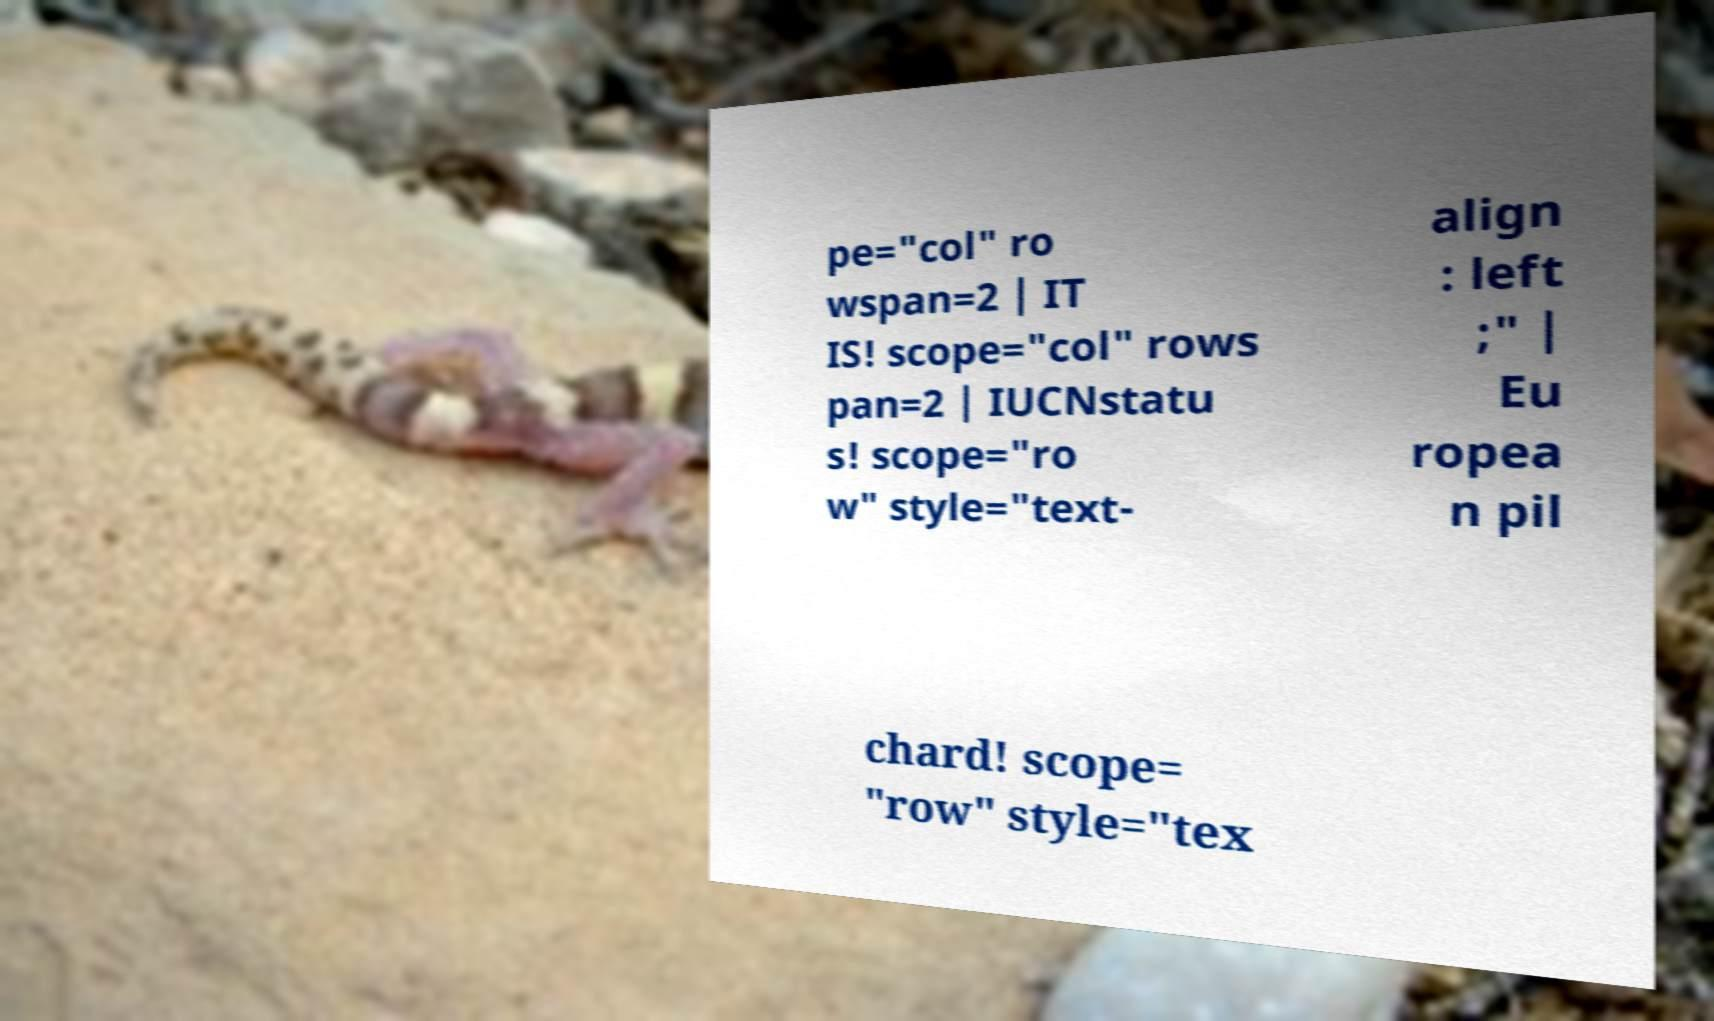Could you extract and type out the text from this image? pe="col" ro wspan=2 | IT IS! scope="col" rows pan=2 | IUCNstatu s! scope="ro w" style="text- align : left ;" | Eu ropea n pil chard! scope= "row" style="tex 